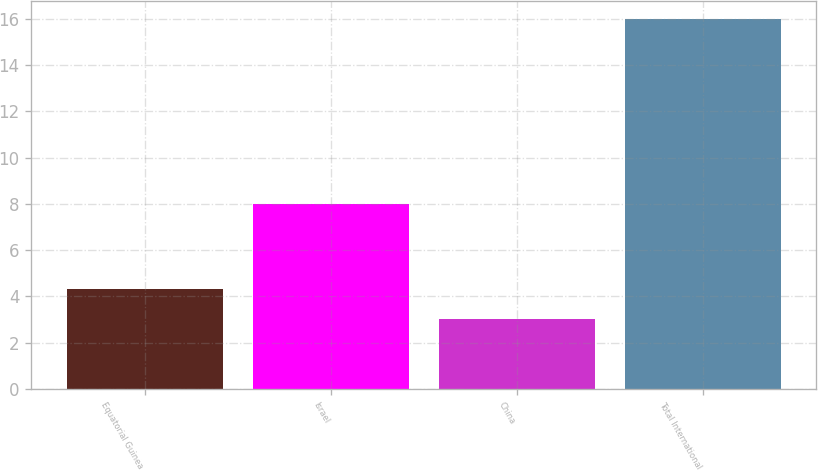Convert chart. <chart><loc_0><loc_0><loc_500><loc_500><bar_chart><fcel>Equatorial Guinea<fcel>Israel<fcel>China<fcel>Total International<nl><fcel>4.3<fcel>8<fcel>3<fcel>16<nl></chart> 